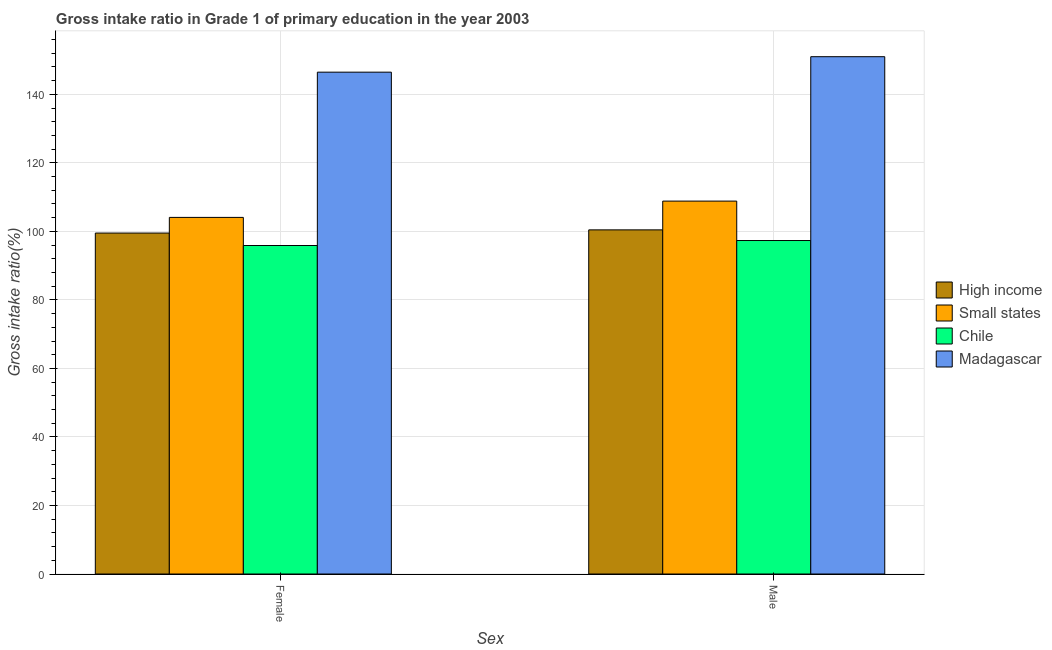How many groups of bars are there?
Offer a terse response. 2. How many bars are there on the 2nd tick from the left?
Offer a terse response. 4. How many bars are there on the 2nd tick from the right?
Your response must be concise. 4. What is the label of the 2nd group of bars from the left?
Your response must be concise. Male. What is the gross intake ratio(female) in High income?
Keep it short and to the point. 99.52. Across all countries, what is the maximum gross intake ratio(male)?
Give a very brief answer. 150.99. Across all countries, what is the minimum gross intake ratio(female)?
Your answer should be very brief. 95.88. In which country was the gross intake ratio(male) maximum?
Your answer should be compact. Madagascar. What is the total gross intake ratio(female) in the graph?
Give a very brief answer. 445.96. What is the difference between the gross intake ratio(female) in Chile and that in High income?
Give a very brief answer. -3.63. What is the difference between the gross intake ratio(female) in High income and the gross intake ratio(male) in Chile?
Make the answer very short. 2.18. What is the average gross intake ratio(male) per country?
Provide a short and direct response. 114.4. What is the difference between the gross intake ratio(female) and gross intake ratio(male) in Chile?
Your answer should be very brief. -1.45. What is the ratio of the gross intake ratio(female) in High income to that in Small states?
Your answer should be very brief. 0.96. Is the gross intake ratio(female) in Chile less than that in Madagascar?
Your answer should be compact. Yes. In how many countries, is the gross intake ratio(male) greater than the average gross intake ratio(male) taken over all countries?
Your response must be concise. 1. What does the 1st bar from the right in Female represents?
Your response must be concise. Madagascar. Does the graph contain grids?
Your answer should be compact. Yes. How many legend labels are there?
Your response must be concise. 4. How are the legend labels stacked?
Your answer should be compact. Vertical. What is the title of the graph?
Give a very brief answer. Gross intake ratio in Grade 1 of primary education in the year 2003. What is the label or title of the X-axis?
Make the answer very short. Sex. What is the label or title of the Y-axis?
Offer a very short reply. Gross intake ratio(%). What is the Gross intake ratio(%) of High income in Female?
Give a very brief answer. 99.52. What is the Gross intake ratio(%) of Small states in Female?
Provide a succinct answer. 104.09. What is the Gross intake ratio(%) of Chile in Female?
Give a very brief answer. 95.88. What is the Gross intake ratio(%) of Madagascar in Female?
Ensure brevity in your answer.  146.48. What is the Gross intake ratio(%) of High income in Male?
Offer a very short reply. 100.44. What is the Gross intake ratio(%) of Small states in Male?
Provide a succinct answer. 108.84. What is the Gross intake ratio(%) of Chile in Male?
Make the answer very short. 97.33. What is the Gross intake ratio(%) of Madagascar in Male?
Offer a terse response. 150.99. Across all Sex, what is the maximum Gross intake ratio(%) of High income?
Your response must be concise. 100.44. Across all Sex, what is the maximum Gross intake ratio(%) of Small states?
Ensure brevity in your answer.  108.84. Across all Sex, what is the maximum Gross intake ratio(%) of Chile?
Offer a very short reply. 97.33. Across all Sex, what is the maximum Gross intake ratio(%) in Madagascar?
Keep it short and to the point. 150.99. Across all Sex, what is the minimum Gross intake ratio(%) of High income?
Provide a succinct answer. 99.52. Across all Sex, what is the minimum Gross intake ratio(%) of Small states?
Your response must be concise. 104.09. Across all Sex, what is the minimum Gross intake ratio(%) of Chile?
Provide a succinct answer. 95.88. Across all Sex, what is the minimum Gross intake ratio(%) in Madagascar?
Your response must be concise. 146.48. What is the total Gross intake ratio(%) in High income in the graph?
Give a very brief answer. 199.96. What is the total Gross intake ratio(%) of Small states in the graph?
Offer a very short reply. 212.93. What is the total Gross intake ratio(%) of Chile in the graph?
Offer a terse response. 193.22. What is the total Gross intake ratio(%) in Madagascar in the graph?
Make the answer very short. 297.47. What is the difference between the Gross intake ratio(%) of High income in Female and that in Male?
Make the answer very short. -0.93. What is the difference between the Gross intake ratio(%) of Small states in Female and that in Male?
Your answer should be compact. -4.76. What is the difference between the Gross intake ratio(%) in Chile in Female and that in Male?
Your answer should be very brief. -1.45. What is the difference between the Gross intake ratio(%) of Madagascar in Female and that in Male?
Provide a succinct answer. -4.51. What is the difference between the Gross intake ratio(%) in High income in Female and the Gross intake ratio(%) in Small states in Male?
Ensure brevity in your answer.  -9.33. What is the difference between the Gross intake ratio(%) in High income in Female and the Gross intake ratio(%) in Chile in Male?
Provide a short and direct response. 2.18. What is the difference between the Gross intake ratio(%) of High income in Female and the Gross intake ratio(%) of Madagascar in Male?
Provide a succinct answer. -51.48. What is the difference between the Gross intake ratio(%) in Small states in Female and the Gross intake ratio(%) in Chile in Male?
Keep it short and to the point. 6.75. What is the difference between the Gross intake ratio(%) in Small states in Female and the Gross intake ratio(%) in Madagascar in Male?
Your response must be concise. -46.91. What is the difference between the Gross intake ratio(%) of Chile in Female and the Gross intake ratio(%) of Madagascar in Male?
Offer a terse response. -55.11. What is the average Gross intake ratio(%) of High income per Sex?
Offer a very short reply. 99.98. What is the average Gross intake ratio(%) in Small states per Sex?
Keep it short and to the point. 106.46. What is the average Gross intake ratio(%) in Chile per Sex?
Offer a terse response. 96.61. What is the average Gross intake ratio(%) of Madagascar per Sex?
Ensure brevity in your answer.  148.74. What is the difference between the Gross intake ratio(%) in High income and Gross intake ratio(%) in Small states in Female?
Keep it short and to the point. -4.57. What is the difference between the Gross intake ratio(%) in High income and Gross intake ratio(%) in Chile in Female?
Your answer should be very brief. 3.63. What is the difference between the Gross intake ratio(%) in High income and Gross intake ratio(%) in Madagascar in Female?
Your answer should be compact. -46.96. What is the difference between the Gross intake ratio(%) in Small states and Gross intake ratio(%) in Chile in Female?
Provide a short and direct response. 8.2. What is the difference between the Gross intake ratio(%) of Small states and Gross intake ratio(%) of Madagascar in Female?
Give a very brief answer. -42.39. What is the difference between the Gross intake ratio(%) of Chile and Gross intake ratio(%) of Madagascar in Female?
Make the answer very short. -50.6. What is the difference between the Gross intake ratio(%) of High income and Gross intake ratio(%) of Small states in Male?
Give a very brief answer. -8.4. What is the difference between the Gross intake ratio(%) in High income and Gross intake ratio(%) in Chile in Male?
Provide a succinct answer. 3.11. What is the difference between the Gross intake ratio(%) of High income and Gross intake ratio(%) of Madagascar in Male?
Provide a succinct answer. -50.55. What is the difference between the Gross intake ratio(%) of Small states and Gross intake ratio(%) of Chile in Male?
Provide a short and direct response. 11.51. What is the difference between the Gross intake ratio(%) in Small states and Gross intake ratio(%) in Madagascar in Male?
Your answer should be very brief. -42.15. What is the difference between the Gross intake ratio(%) of Chile and Gross intake ratio(%) of Madagascar in Male?
Your answer should be very brief. -53.66. What is the ratio of the Gross intake ratio(%) of High income in Female to that in Male?
Keep it short and to the point. 0.99. What is the ratio of the Gross intake ratio(%) of Small states in Female to that in Male?
Make the answer very short. 0.96. What is the ratio of the Gross intake ratio(%) of Chile in Female to that in Male?
Your answer should be very brief. 0.99. What is the ratio of the Gross intake ratio(%) in Madagascar in Female to that in Male?
Keep it short and to the point. 0.97. What is the difference between the highest and the second highest Gross intake ratio(%) of High income?
Your response must be concise. 0.93. What is the difference between the highest and the second highest Gross intake ratio(%) of Small states?
Your answer should be compact. 4.76. What is the difference between the highest and the second highest Gross intake ratio(%) in Chile?
Ensure brevity in your answer.  1.45. What is the difference between the highest and the second highest Gross intake ratio(%) of Madagascar?
Offer a terse response. 4.51. What is the difference between the highest and the lowest Gross intake ratio(%) in High income?
Provide a succinct answer. 0.93. What is the difference between the highest and the lowest Gross intake ratio(%) of Small states?
Your response must be concise. 4.76. What is the difference between the highest and the lowest Gross intake ratio(%) in Chile?
Offer a very short reply. 1.45. What is the difference between the highest and the lowest Gross intake ratio(%) of Madagascar?
Give a very brief answer. 4.51. 